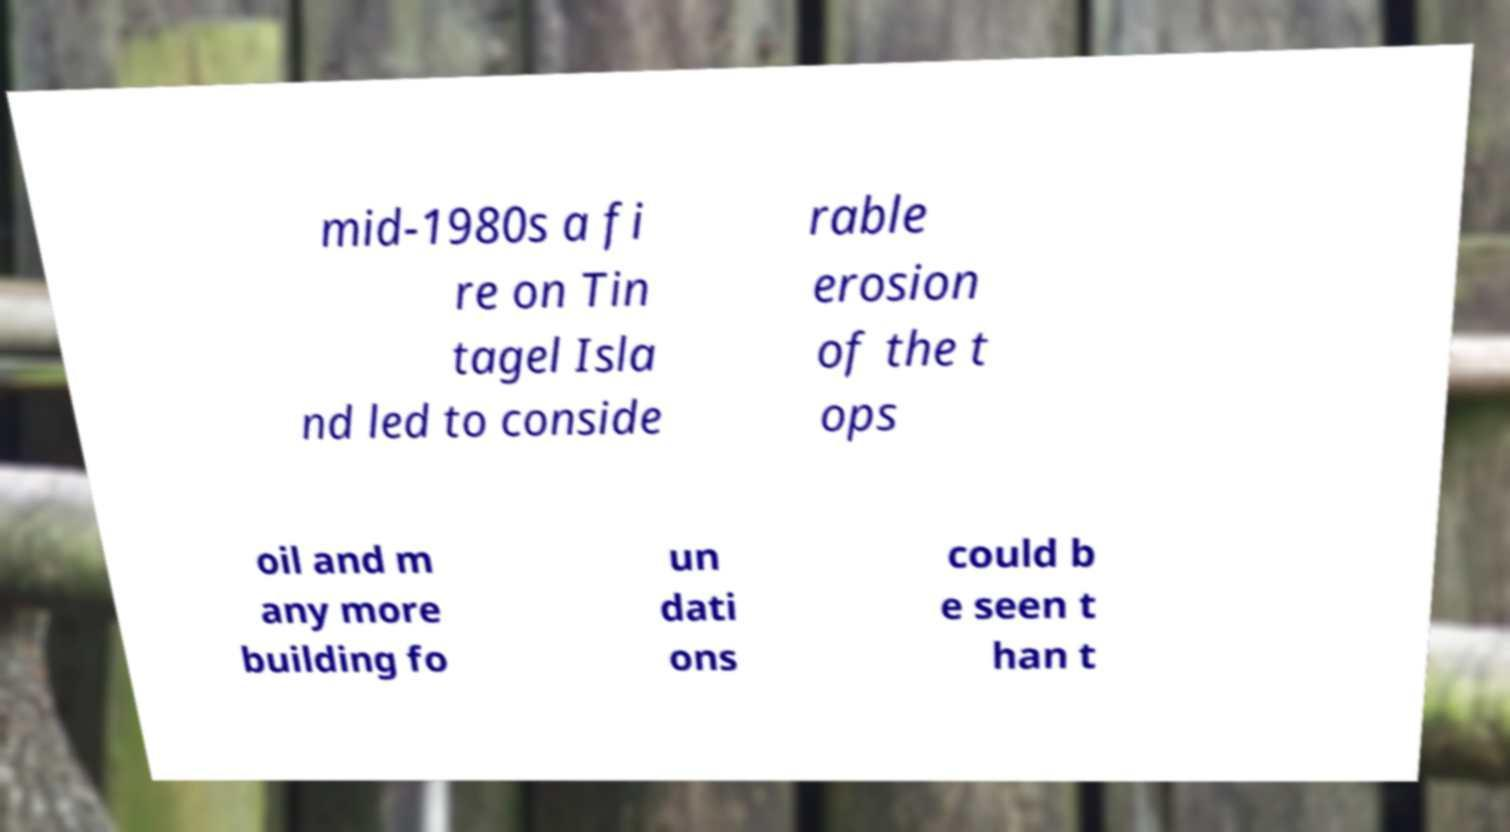Could you extract and type out the text from this image? mid-1980s a fi re on Tin tagel Isla nd led to conside rable erosion of the t ops oil and m any more building fo un dati ons could b e seen t han t 